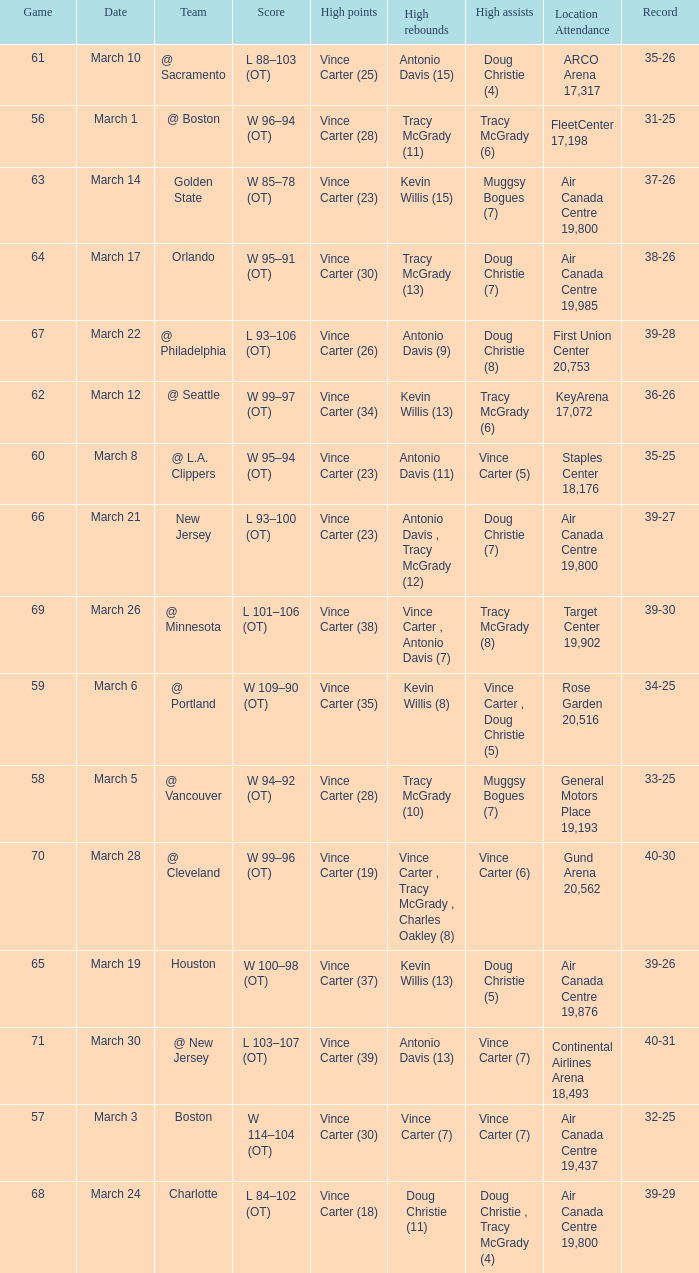Who was the high rebounder against charlotte? Doug Christie (11). 